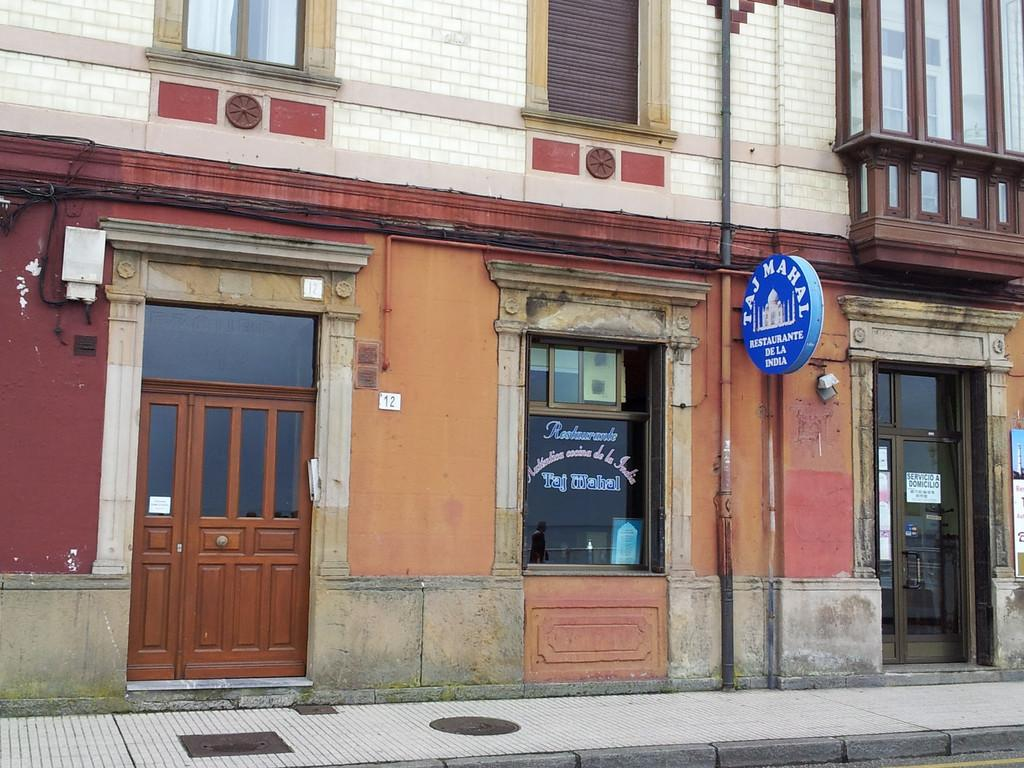What type of structure is visible in the image? There is a building in the image. What features can be seen on the building? The building has doors and windows. Is there any signage on the building? Yes, there is a name board attached to the building wall. What is visible at the bottom of the image? There is a pathway at the bottom of the image. How can someone use the map to measure the distance between the building and the pathway in the image? There is no map present in the image, so it cannot be used to measure the distance between the building and the pathway. 